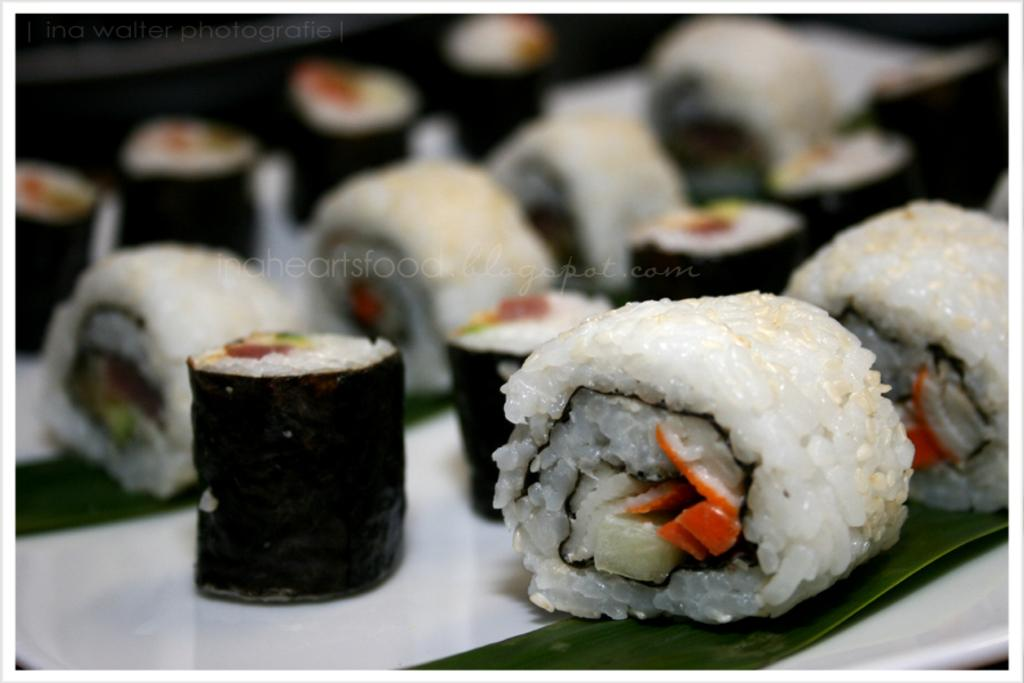What is present in the image that people typically consume? There is food in the image. What type of plant material is visible in the image? There are leaves in the image. On what surface are the food and leaves placed? The food and leaves are on a white object. How would you describe the appearance of the background in the image? The background of the image is blurred. Are there any visible marks on the image that might indicate its origin or authenticity? Yes, there are watermarks on the image. Can you see any crayons in the image? No, there are no crayons present in the image. Is there a sense of harmony between the food and leaves in the image? The concept of harmony is subjective and cannot be definitively determined from the image. 